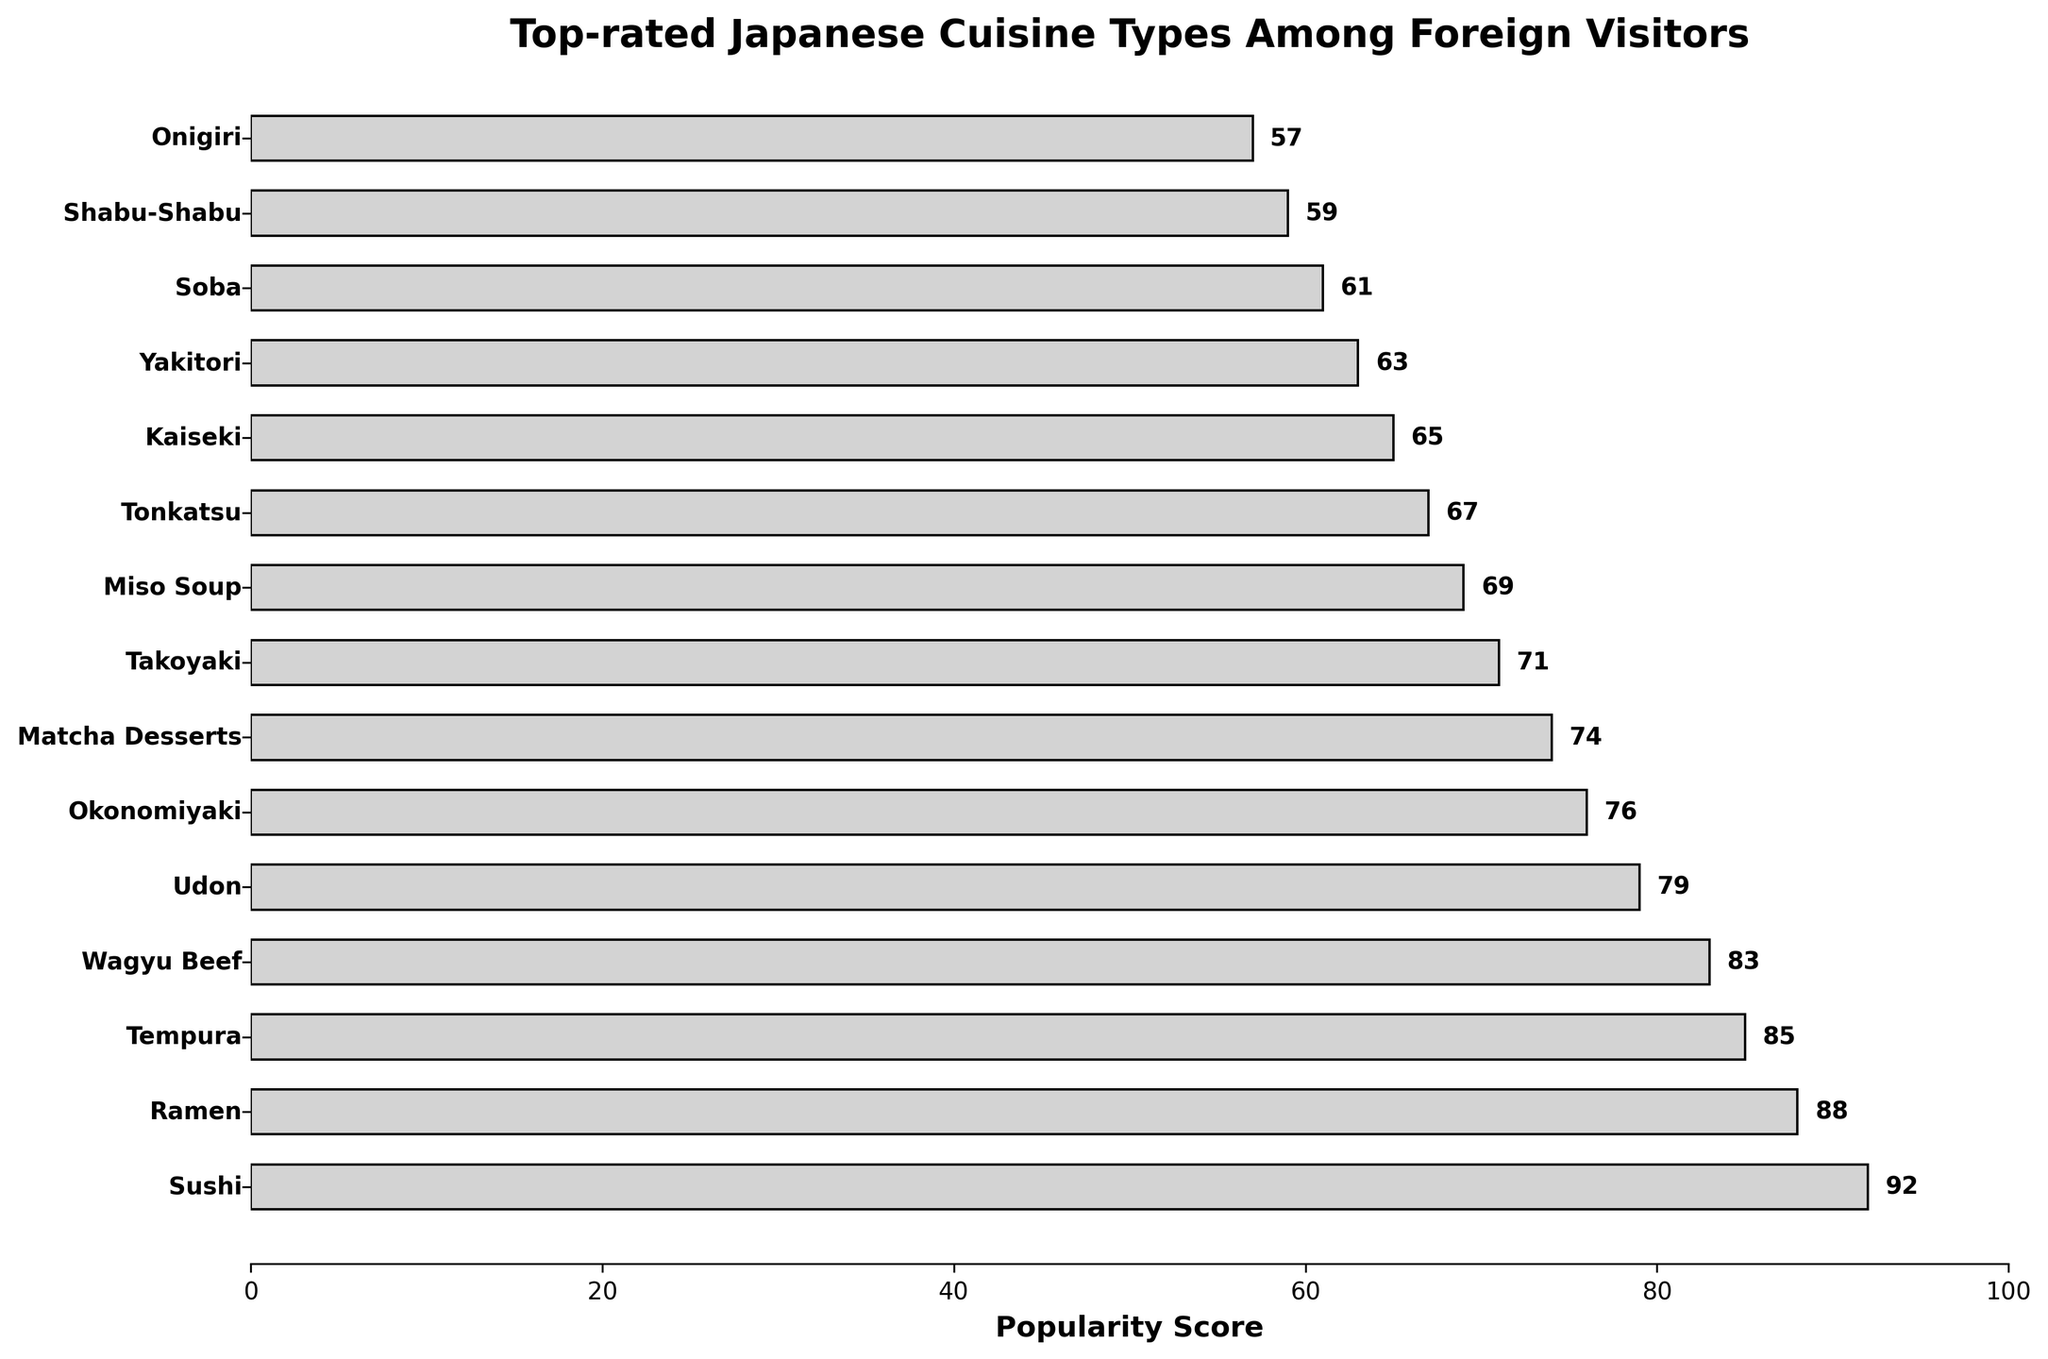Which cuisine type is the most popular among foreign visitors? The bar chart shows that "Sushi" has the highest popularity score with 92.
Answer: Sushi Between Ramen and Tempura, which cuisine type has a higher popularity score? According to the chart, "Ramen" has a popularity score of 88, while "Tempura" has a score of 85.
Answer: Ramen What's the combined popularity score of Wagyu Beef and Udon? The popularity score of Wagyu Beef is 83, and Udon is 79. Adding them together: 83 + 79 = 162.
Answer: 162 Which cuisine type has a lower popularity score, Takoyaki or Yakitori? Takoyaki has a popularity score of 71, while Yakitori has a score of 63. Therefore, Yakitori has a lower score.
Answer: Yakitori What is the average popularity score of the top three cuisine types? The top three cuisine types and their scores are Sushi (92), Ramen (88), and Tempura (85). The average is calculated as (92 + 88 + 85) / 3 = 265 / 3 = 88.33.
Answer: 88.33 Which cuisine type is just as popular as Kaiseki? Kaiseki has a popularity score of 65. There isn't another cuisine type with the exact same popularity score.
Answer: None How many cuisine types have a popularity score above 70? According to the chart, 8 cuisine types have a score above 70: Sushi, Ramen, Tempura, Wagyu Beef, Udon, Okonomiyaki, Matcha Desserts, and Takoyaki.
Answer: 8 Which is the least popular cuisine type among foreign visitors? The cuisine type with the lowest popularity score is Onigiri, with a score of 57.
Answer: Onigiri How much more popular is Sushi compared to Tonkatsu? Sushi has a popularity score of 92, while Tonkatsu has a score of 67. The difference is 92 - 67 = 25.
Answer: 25 